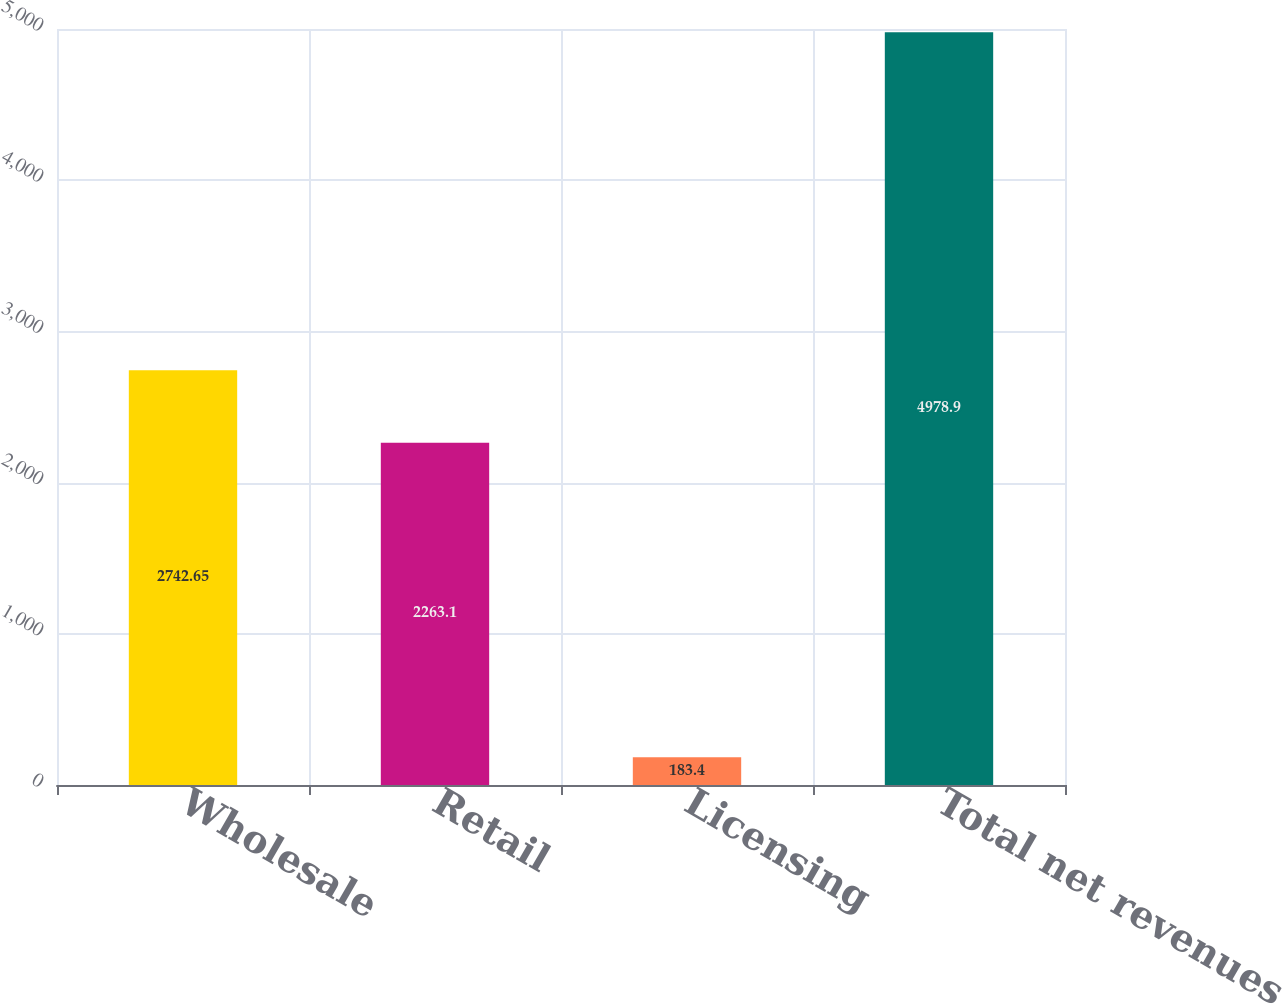<chart> <loc_0><loc_0><loc_500><loc_500><bar_chart><fcel>Wholesale<fcel>Retail<fcel>Licensing<fcel>Total net revenues<nl><fcel>2742.65<fcel>2263.1<fcel>183.4<fcel>4978.9<nl></chart> 